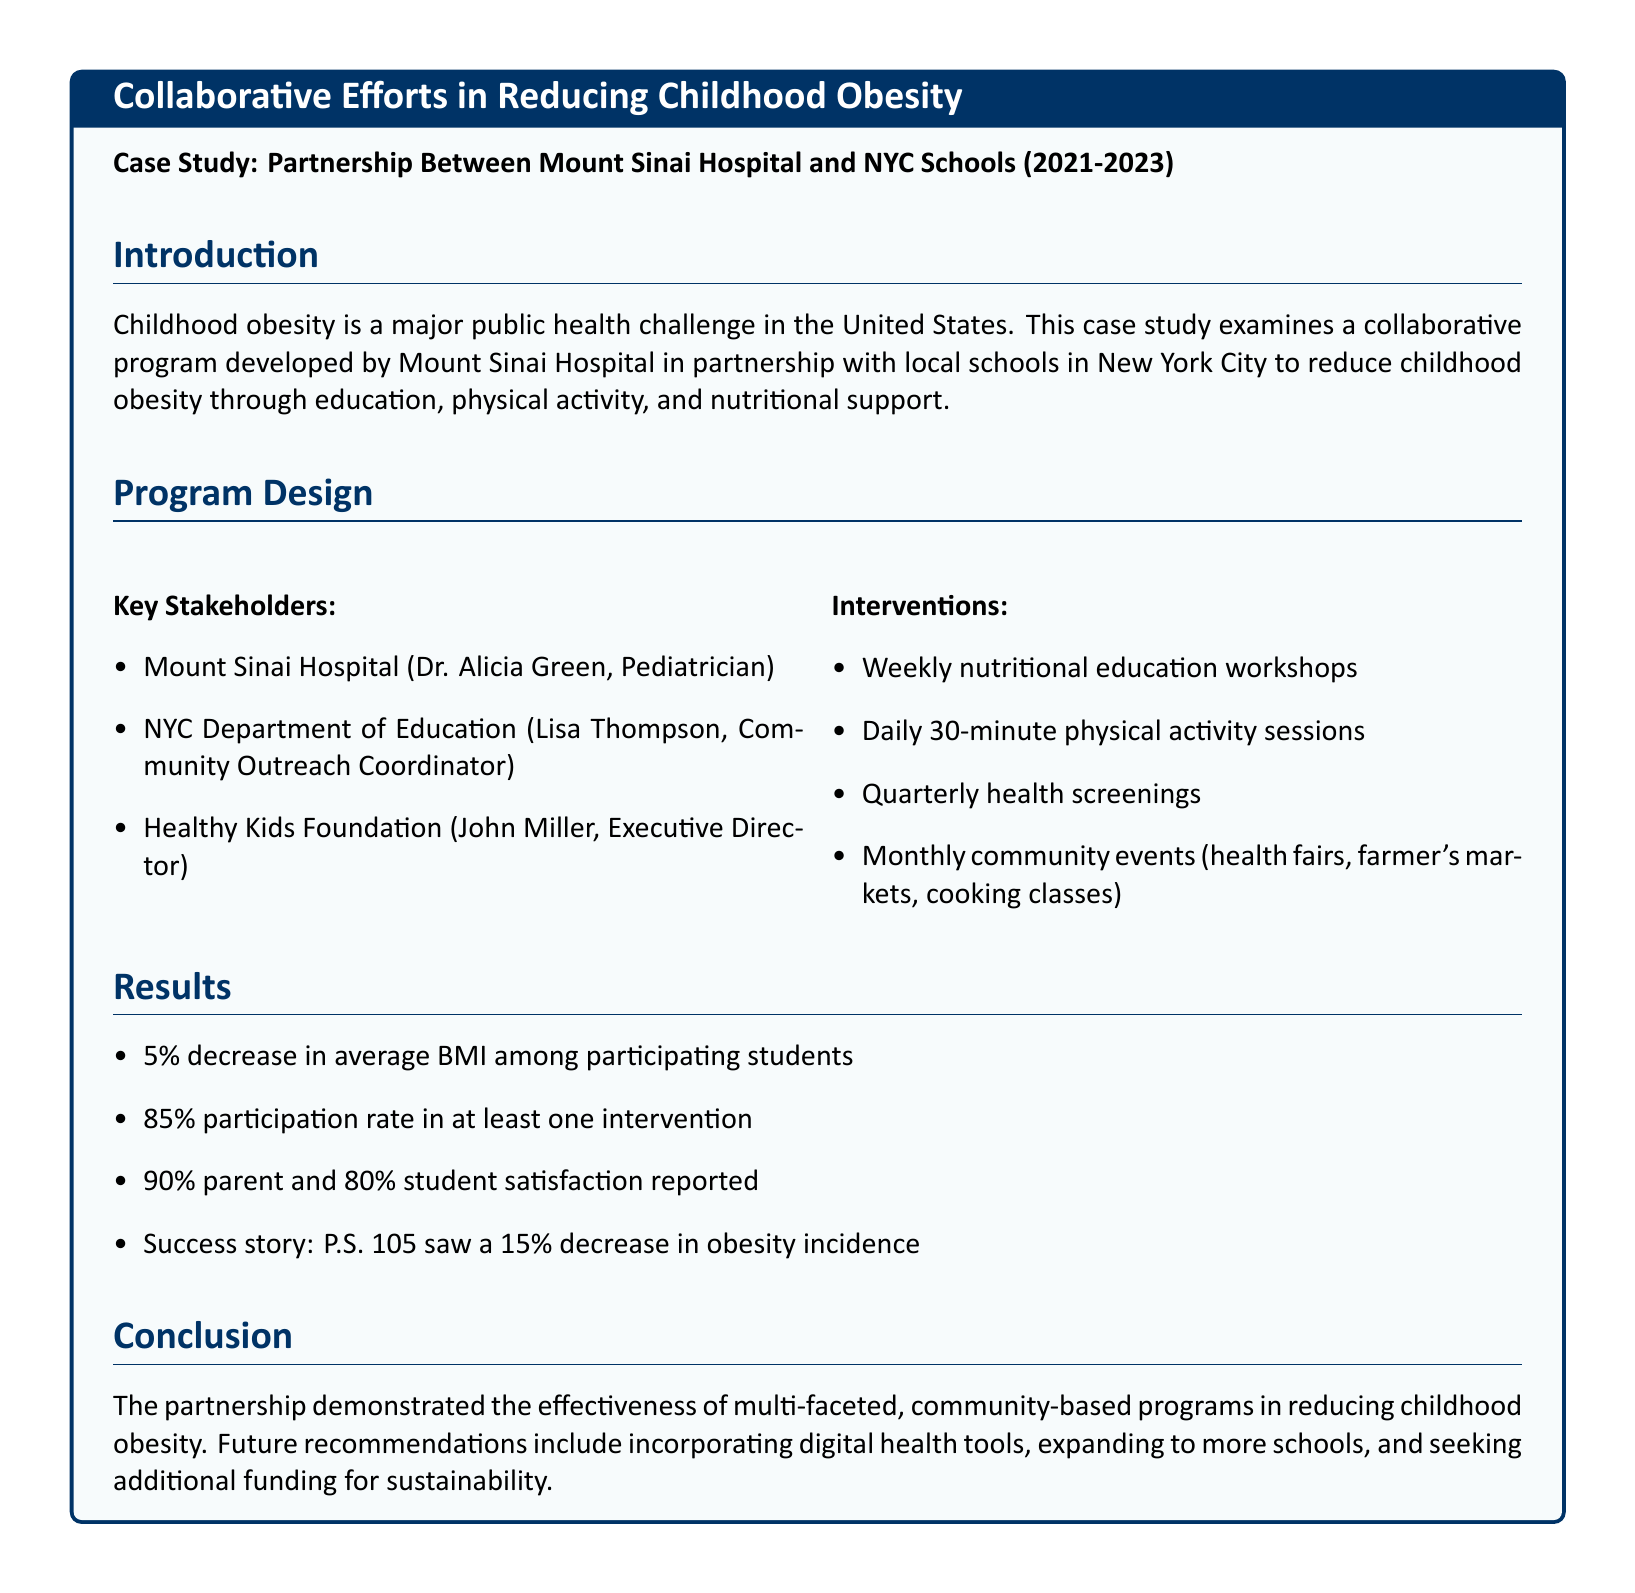What is the partnership involved in this case study? The partnership is between Mount Sinai Hospital and NYC Schools, aimed at reducing childhood obesity.
Answer: Mount Sinai Hospital and NYC Schools Who is the Pediatrician associated with the program? Dr. Alicia Green is identified as the Pediatrician from Mount Sinai Hospital involved in the program.
Answer: Dr. Alicia Green What percentage decrease in average BMI was reported? The document states a 5% decrease in average BMI among participating students.
Answer: 5% Which school reported a 15% decrease in obesity incidence? P.S. 105 is the school that reported this significant decrease in obesity incidence.
Answer: P.S. 105 What activities were included in the interventions? The interventions included weekly nutritional education workshops and daily physical activity sessions, among others.
Answer: Nutritional education workshops, physical activity sessions What was the participation rate in at least one intervention? An 85% participation rate in at least one intervention was reported in the results.
Answer: 85% What is one recommendation for future efforts mentioned? The recommendation includes incorporating digital health tools for enhancing program effectiveness.
Answer: Incorporating digital health tools What was the satisfaction rate among parents? The document indicates a 90% satisfaction rate reported by parents regarding the program.
Answer: 90% When was the program conducted? The program was conducted between 2021 and 2023, as stated in the introduction.
Answer: 2021-2023 